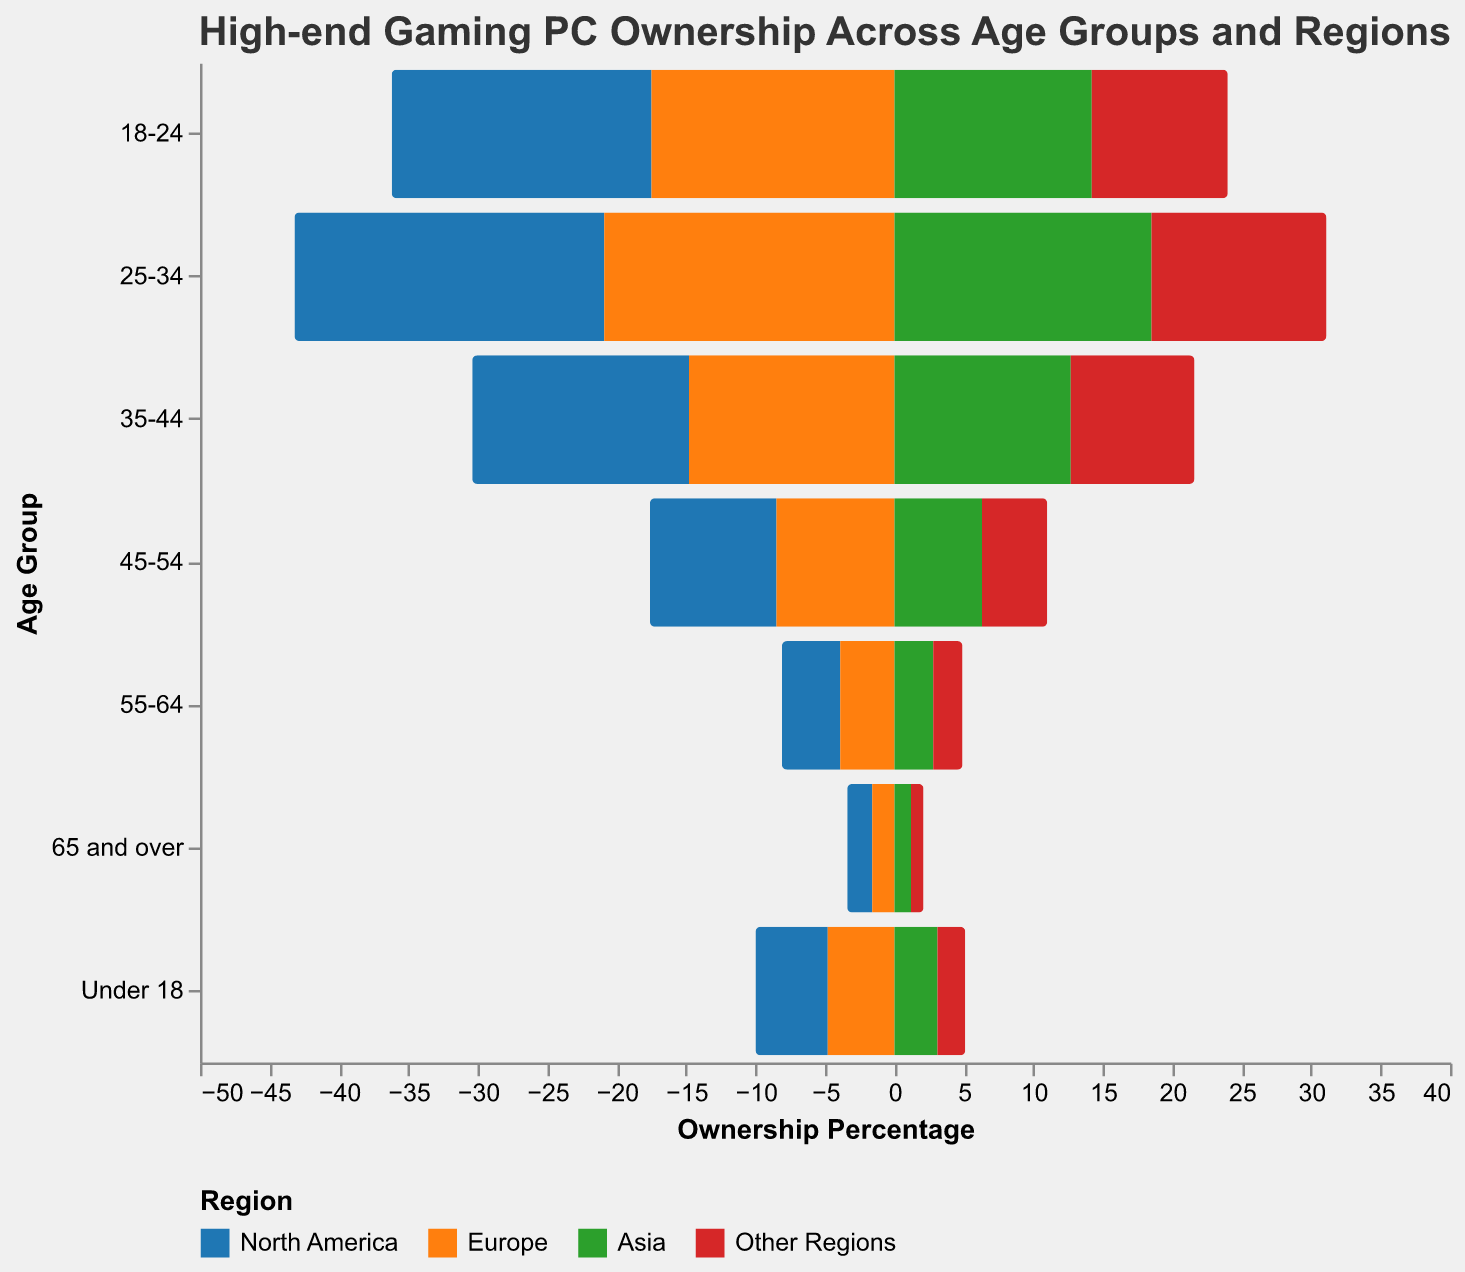What is the title of the figure? Look at the top of the figure for the header text.
Answer: High-end Gaming PC Ownership Across Age Groups and Regions Which region has the highest ownership of high-end gaming PCs in the 25-34 age group? Identify the bars corresponding to the 25-34 age group and compare their values across regions. The highest bar indicates the region.
Answer: North America At what age group does high-end gaming PC ownership start to significantly decline in North America? Observe the North America's values across age groups and notice the point where the percentage drops considerably.
Answer: 35-44 Which age group in Asia has a higher percentage of high-end gaming PC ownership compared to North America’s under 18 group? Compare the percentage values for the "Under 18" in North America and each age group in Asia. Look for an age group in Asia with a percentage higher than 5.2%.
Answer: 25-34 What is the combined percentage of high-end gaming PC ownership in the 18-24 age group across Europe and Asia? Sum the percentages of the 18-24 age group for Europe and Asia (17.5 + 14.2).
Answer: 31.7% How does the ownership percentage in the 55-64 age group in Europe compare to North America and Asia? Compare the 55-64 age group's values for Europe (3.9), North America (4.2), and Asia (2.8). Find if Europe’s percentage is greater than, less than, or equal to the others.
Answer: Higher than Asia, lower than North America What is the overall trend of high-end gaming PC ownership as age increases in all regions? Examine each region's bar heights as the age groups progress from younger to older.
Answer: Decreases For the 35-44 age group, how much more popular are high-end gaming PCs in North America compared to Other Regions? Subtract Other Regions' percentage in the 35-44 age group from North America's percentage (15.6 - 8.9).
Answer: 6.7% Identify the age group with the smallest difference in high-end gaming PC ownership between North America and Europe. Calculate the absolute difference between North America and Europe for each age group and identify the smallest value.
Answer: 65 and over In the "Other Regions" category, which age group shows the highest ownership percentage? Find the highest value among all age groups for Other Regions.
Answer: 25-34 